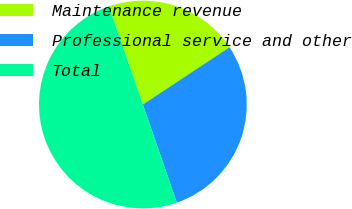Convert chart to OTSL. <chart><loc_0><loc_0><loc_500><loc_500><pie_chart><fcel>Maintenance revenue<fcel>Professional service and other<fcel>Total<nl><fcel>21.0%<fcel>29.0%<fcel>50.0%<nl></chart> 